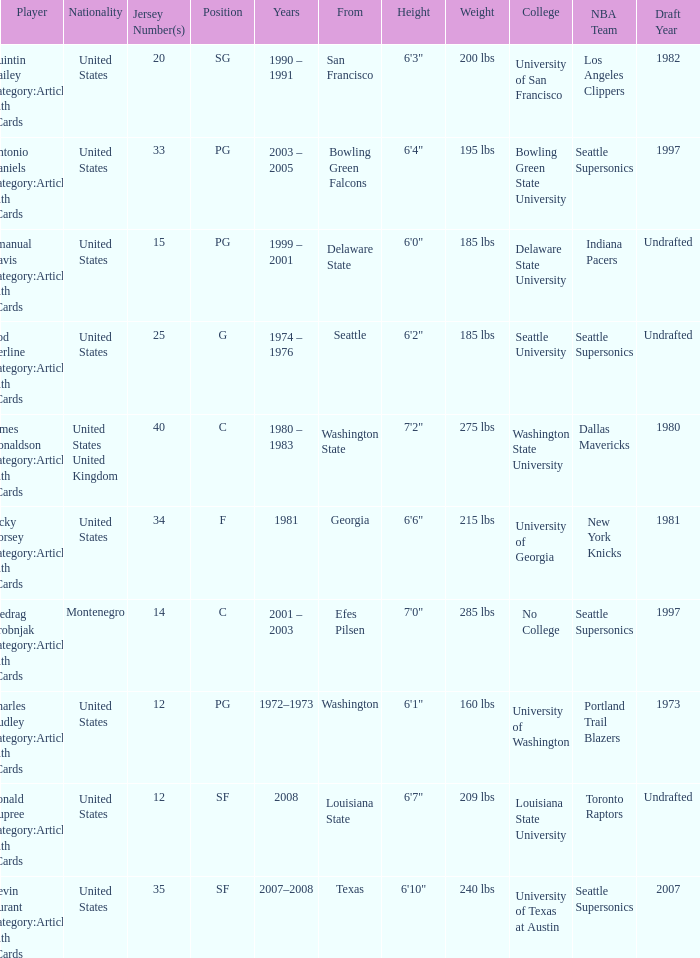Can you parse all the data within this table? {'header': ['Player', 'Nationality', 'Jersey Number(s)', 'Position', 'Years', 'From', 'Height', 'Weight', 'College', 'NBA Team', 'Draft Year'], 'rows': [['Quintin Dailey Category:Articles with hCards', 'United States', '20', 'SG', '1990 – 1991', 'San Francisco', '6\'3"', '200 lbs', 'University of San Francisco', 'Los Angeles Clippers', '1982'], ['Antonio Daniels Category:Articles with hCards', 'United States', '33', 'PG', '2003 – 2005', 'Bowling Green Falcons', '6\'4"', '195 lbs', 'Bowling Green State University', 'Seattle Supersonics', '1997'], ['Emanual Davis Category:Articles with hCards', 'United States', '15', 'PG', '1999 – 2001', 'Delaware State', '6\'0"', '185 lbs', 'Delaware State University', 'Indiana Pacers', 'Undrafted'], ['Rod Derline Category:Articles with hCards', 'United States', '25', 'G', '1974 – 1976', 'Seattle', '6\'2"', '185 lbs', 'Seattle University', 'Seattle Supersonics', 'Undrafted'], ['James Donaldson Category:Articles with hCards', 'United States United Kingdom', '40', 'C', '1980 – 1983', 'Washington State', '7\'2"', '275 lbs', 'Washington State University', 'Dallas Mavericks', '1980'], ['Jacky Dorsey Category:Articles with hCards', 'United States', '34', 'F', '1981', 'Georgia', '6\'6"', '215 lbs', 'University of Georgia', 'New York Knicks', '1981'], ['Predrag Drobnjak Category:Articles with hCards', 'Montenegro', '14', 'C', '2001 – 2003', 'Efes Pilsen', '7\'0"', '285 lbs', 'No College', 'Seattle Supersonics', '1997'], ['Charles Dudley Category:Articles with hCards', 'United States', '12', 'PG', '1972–1973', 'Washington', '6\'1"', '160 lbs', 'University of Washington', 'Portland Trail Blazers', '1973'], ['Ronald Dupree Category:Articles with hCards', 'United States', '12', 'SF', '2008', 'Louisiana State', '6\'7"', '209 lbs', 'Louisiana State University', 'Toronto Raptors', 'Undrafted'], ['Kevin Durant Category:Articles with hCards', 'United States', '35', 'SF', '2007–2008', 'Texas', '6\'10"', '240 lbs', 'University of Texas at Austin', 'Seattle Supersonics', '2007']]} What years did the united states player with a jersey number 25 who attended delaware state play? 1999 – 2001. 